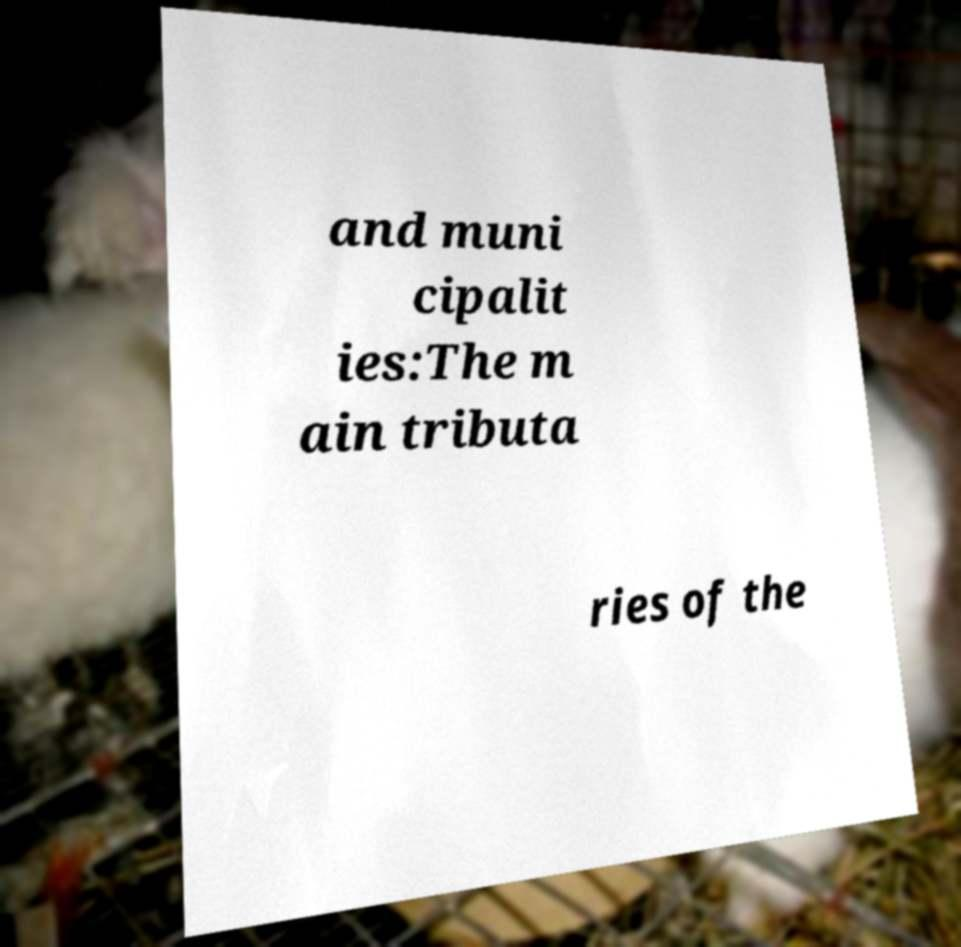Could you extract and type out the text from this image? and muni cipalit ies:The m ain tributa ries of the 